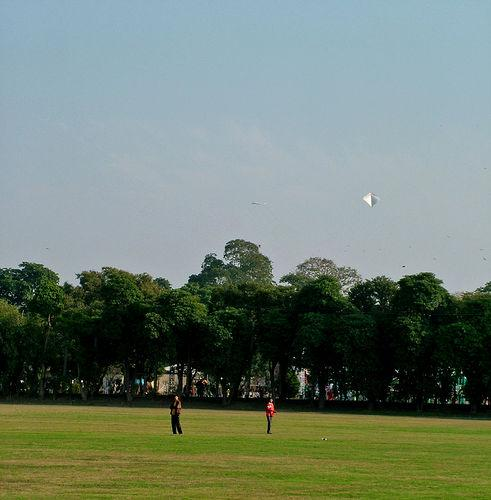What is the best shape for a kite? Please explain your reasoning. diamond. Triangle shaped kites are the most common and know to be the best for flight. 